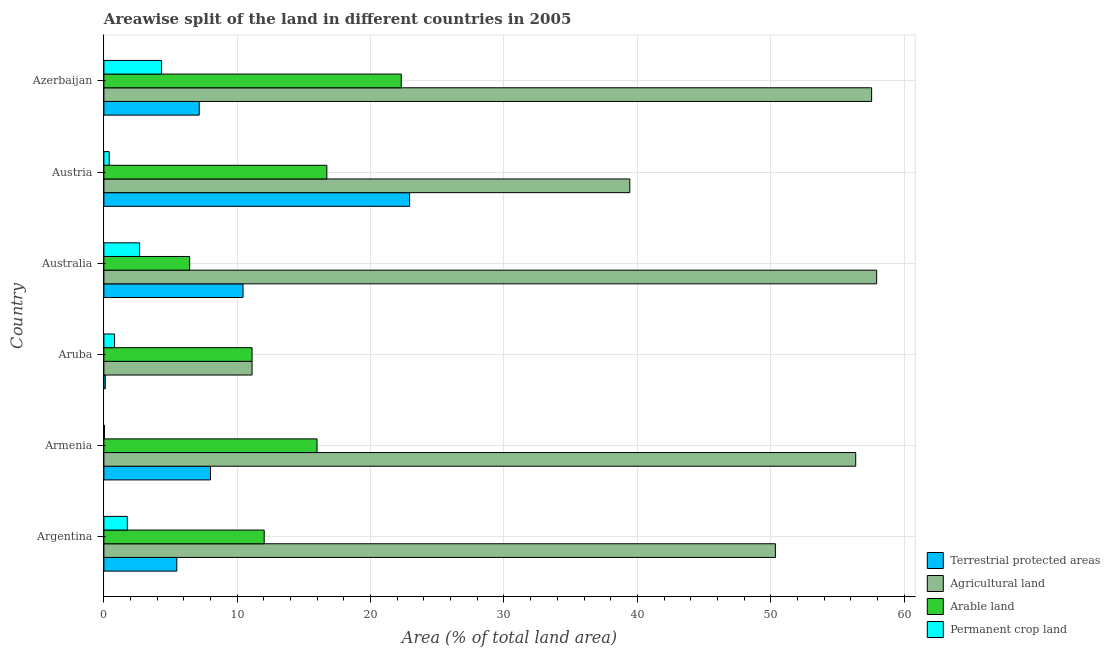How many different coloured bars are there?
Your answer should be compact. 4. Are the number of bars on each tick of the Y-axis equal?
Provide a succinct answer. Yes. How many bars are there on the 6th tick from the top?
Offer a terse response. 4. What is the label of the 1st group of bars from the top?
Your answer should be compact. Azerbaijan. What is the percentage of area under permanent crop land in Australia?
Keep it short and to the point. 2.68. Across all countries, what is the maximum percentage of area under permanent crop land?
Provide a short and direct response. 4.32. Across all countries, what is the minimum percentage of area under agricultural land?
Your answer should be very brief. 11.11. In which country was the percentage of area under agricultural land maximum?
Make the answer very short. Australia. In which country was the percentage of area under agricultural land minimum?
Give a very brief answer. Aruba. What is the total percentage of land under terrestrial protection in the graph?
Keep it short and to the point. 54.07. What is the difference between the percentage of area under agricultural land in Australia and that in Azerbaijan?
Provide a short and direct response. 0.38. What is the difference between the percentage of area under permanent crop land in Argentina and the percentage of land under terrestrial protection in Aruba?
Keep it short and to the point. 1.65. What is the average percentage of area under arable land per country?
Offer a terse response. 14.09. What is the difference between the percentage of area under agricultural land and percentage of area under arable land in Azerbaijan?
Your answer should be compact. 35.27. In how many countries, is the percentage of area under arable land greater than 36 %?
Provide a succinct answer. 0. What is the ratio of the percentage of area under agricultural land in Argentina to that in Australia?
Ensure brevity in your answer.  0.87. Is the difference between the percentage of area under agricultural land in Austria and Azerbaijan greater than the difference between the percentage of area under arable land in Austria and Azerbaijan?
Your answer should be very brief. No. What is the difference between the highest and the second highest percentage of area under agricultural land?
Your answer should be very brief. 0.38. What is the difference between the highest and the lowest percentage of area under agricultural land?
Your answer should be very brief. 46.83. In how many countries, is the percentage of area under agricultural land greater than the average percentage of area under agricultural land taken over all countries?
Your answer should be very brief. 4. Is the sum of the percentage of land under terrestrial protection in Armenia and Austria greater than the maximum percentage of area under arable land across all countries?
Provide a short and direct response. Yes. Is it the case that in every country, the sum of the percentage of area under agricultural land and percentage of area under arable land is greater than the sum of percentage of area under permanent crop land and percentage of land under terrestrial protection?
Offer a very short reply. No. What does the 4th bar from the top in Argentina represents?
Your answer should be very brief. Terrestrial protected areas. What does the 2nd bar from the bottom in Austria represents?
Provide a short and direct response. Agricultural land. What is the difference between two consecutive major ticks on the X-axis?
Offer a terse response. 10. Where does the legend appear in the graph?
Your answer should be compact. Bottom right. How are the legend labels stacked?
Make the answer very short. Vertical. What is the title of the graph?
Your response must be concise. Areawise split of the land in different countries in 2005. What is the label or title of the X-axis?
Make the answer very short. Area (% of total land area). What is the Area (% of total land area) of Terrestrial protected areas in Argentina?
Provide a succinct answer. 5.47. What is the Area (% of total land area) in Agricultural land in Argentina?
Provide a succinct answer. 50.35. What is the Area (% of total land area) of Arable land in Argentina?
Give a very brief answer. 12.02. What is the Area (% of total land area) in Permanent crop land in Argentina?
Provide a short and direct response. 1.76. What is the Area (% of total land area) of Terrestrial protected areas in Armenia?
Provide a short and direct response. 7.99. What is the Area (% of total land area) in Agricultural land in Armenia?
Make the answer very short. 56.38. What is the Area (% of total land area) in Arable land in Armenia?
Make the answer very short. 15.98. What is the Area (% of total land area) in Permanent crop land in Armenia?
Provide a short and direct response. 0.04. What is the Area (% of total land area) of Terrestrial protected areas in Aruba?
Provide a succinct answer. 0.11. What is the Area (% of total land area) in Agricultural land in Aruba?
Provide a succinct answer. 11.11. What is the Area (% of total land area) in Arable land in Aruba?
Ensure brevity in your answer.  11.11. What is the Area (% of total land area) in Permanent crop land in Aruba?
Provide a succinct answer. 0.8. What is the Area (% of total land area) of Terrestrial protected areas in Australia?
Your answer should be compact. 10.43. What is the Area (% of total land area) in Agricultural land in Australia?
Your answer should be compact. 57.94. What is the Area (% of total land area) of Arable land in Australia?
Your answer should be very brief. 6.43. What is the Area (% of total land area) of Permanent crop land in Australia?
Give a very brief answer. 2.68. What is the Area (% of total land area) in Terrestrial protected areas in Austria?
Your response must be concise. 22.92. What is the Area (% of total land area) in Agricultural land in Austria?
Offer a terse response. 39.44. What is the Area (% of total land area) in Arable land in Austria?
Provide a succinct answer. 16.72. What is the Area (% of total land area) in Permanent crop land in Austria?
Provide a succinct answer. 0.4. What is the Area (% of total land area) of Terrestrial protected areas in Azerbaijan?
Offer a terse response. 7.15. What is the Area (% of total land area) in Agricultural land in Azerbaijan?
Offer a terse response. 57.57. What is the Area (% of total land area) of Arable land in Azerbaijan?
Provide a short and direct response. 22.3. What is the Area (% of total land area) of Permanent crop land in Azerbaijan?
Offer a terse response. 4.32. Across all countries, what is the maximum Area (% of total land area) in Terrestrial protected areas?
Your answer should be compact. 22.92. Across all countries, what is the maximum Area (% of total land area) of Agricultural land?
Keep it short and to the point. 57.94. Across all countries, what is the maximum Area (% of total land area) in Arable land?
Your response must be concise. 22.3. Across all countries, what is the maximum Area (% of total land area) of Permanent crop land?
Offer a very short reply. 4.32. Across all countries, what is the minimum Area (% of total land area) of Terrestrial protected areas?
Make the answer very short. 0.11. Across all countries, what is the minimum Area (% of total land area) of Agricultural land?
Ensure brevity in your answer.  11.11. Across all countries, what is the minimum Area (% of total land area) of Arable land?
Your answer should be compact. 6.43. Across all countries, what is the minimum Area (% of total land area) in Permanent crop land?
Provide a short and direct response. 0.04. What is the total Area (% of total land area) in Terrestrial protected areas in the graph?
Provide a succinct answer. 54.07. What is the total Area (% of total land area) of Agricultural land in the graph?
Your answer should be compact. 272.79. What is the total Area (% of total land area) in Arable land in the graph?
Provide a short and direct response. 84.56. What is the total Area (% of total land area) in Permanent crop land in the graph?
Your answer should be very brief. 10. What is the difference between the Area (% of total land area) of Terrestrial protected areas in Argentina and that in Armenia?
Give a very brief answer. -2.53. What is the difference between the Area (% of total land area) of Agricultural land in Argentina and that in Armenia?
Offer a very short reply. -6.02. What is the difference between the Area (% of total land area) of Arable land in Argentina and that in Armenia?
Offer a terse response. -3.96. What is the difference between the Area (% of total land area) in Permanent crop land in Argentina and that in Armenia?
Give a very brief answer. 1.71. What is the difference between the Area (% of total land area) in Terrestrial protected areas in Argentina and that in Aruba?
Make the answer very short. 5.36. What is the difference between the Area (% of total land area) in Agricultural land in Argentina and that in Aruba?
Provide a short and direct response. 39.24. What is the difference between the Area (% of total land area) of Arable land in Argentina and that in Aruba?
Offer a very short reply. 0.91. What is the difference between the Area (% of total land area) of Terrestrial protected areas in Argentina and that in Australia?
Offer a terse response. -4.97. What is the difference between the Area (% of total land area) of Agricultural land in Argentina and that in Australia?
Your response must be concise. -7.59. What is the difference between the Area (% of total land area) of Arable land in Argentina and that in Australia?
Offer a very short reply. 5.59. What is the difference between the Area (% of total land area) in Permanent crop land in Argentina and that in Australia?
Ensure brevity in your answer.  -0.92. What is the difference between the Area (% of total land area) of Terrestrial protected areas in Argentina and that in Austria?
Your answer should be compact. -17.46. What is the difference between the Area (% of total land area) in Agricultural land in Argentina and that in Austria?
Offer a very short reply. 10.92. What is the difference between the Area (% of total land area) of Arable land in Argentina and that in Austria?
Offer a terse response. -4.7. What is the difference between the Area (% of total land area) in Permanent crop land in Argentina and that in Austria?
Ensure brevity in your answer.  1.36. What is the difference between the Area (% of total land area) of Terrestrial protected areas in Argentina and that in Azerbaijan?
Ensure brevity in your answer.  -1.68. What is the difference between the Area (% of total land area) in Agricultural land in Argentina and that in Azerbaijan?
Your response must be concise. -7.22. What is the difference between the Area (% of total land area) in Arable land in Argentina and that in Azerbaijan?
Keep it short and to the point. -10.28. What is the difference between the Area (% of total land area) of Permanent crop land in Argentina and that in Azerbaijan?
Your answer should be very brief. -2.57. What is the difference between the Area (% of total land area) of Terrestrial protected areas in Armenia and that in Aruba?
Provide a short and direct response. 7.89. What is the difference between the Area (% of total land area) of Agricultural land in Armenia and that in Aruba?
Offer a terse response. 45.26. What is the difference between the Area (% of total land area) of Arable land in Armenia and that in Aruba?
Ensure brevity in your answer.  4.87. What is the difference between the Area (% of total land area) in Permanent crop land in Armenia and that in Aruba?
Keep it short and to the point. -0.76. What is the difference between the Area (% of total land area) in Terrestrial protected areas in Armenia and that in Australia?
Give a very brief answer. -2.44. What is the difference between the Area (% of total land area) of Agricultural land in Armenia and that in Australia?
Your answer should be very brief. -1.57. What is the difference between the Area (% of total land area) of Arable land in Armenia and that in Australia?
Provide a succinct answer. 9.55. What is the difference between the Area (% of total land area) in Permanent crop land in Armenia and that in Australia?
Ensure brevity in your answer.  -2.64. What is the difference between the Area (% of total land area) of Terrestrial protected areas in Armenia and that in Austria?
Your response must be concise. -14.93. What is the difference between the Area (% of total land area) of Agricultural land in Armenia and that in Austria?
Your response must be concise. 16.94. What is the difference between the Area (% of total land area) in Arable land in Armenia and that in Austria?
Your response must be concise. -0.74. What is the difference between the Area (% of total land area) of Permanent crop land in Armenia and that in Austria?
Your answer should be compact. -0.36. What is the difference between the Area (% of total land area) in Terrestrial protected areas in Armenia and that in Azerbaijan?
Keep it short and to the point. 0.84. What is the difference between the Area (% of total land area) in Agricultural land in Armenia and that in Azerbaijan?
Your answer should be very brief. -1.19. What is the difference between the Area (% of total land area) in Arable land in Armenia and that in Azerbaijan?
Provide a succinct answer. -6.32. What is the difference between the Area (% of total land area) of Permanent crop land in Armenia and that in Azerbaijan?
Give a very brief answer. -4.28. What is the difference between the Area (% of total land area) of Terrestrial protected areas in Aruba and that in Australia?
Your response must be concise. -10.33. What is the difference between the Area (% of total land area) of Agricultural land in Aruba and that in Australia?
Give a very brief answer. -46.83. What is the difference between the Area (% of total land area) in Arable land in Aruba and that in Australia?
Your answer should be compact. 4.68. What is the difference between the Area (% of total land area) of Permanent crop land in Aruba and that in Australia?
Your answer should be compact. -1.88. What is the difference between the Area (% of total land area) of Terrestrial protected areas in Aruba and that in Austria?
Ensure brevity in your answer.  -22.82. What is the difference between the Area (% of total land area) in Agricultural land in Aruba and that in Austria?
Offer a terse response. -28.33. What is the difference between the Area (% of total land area) in Arable land in Aruba and that in Austria?
Make the answer very short. -5.61. What is the difference between the Area (% of total land area) of Permanent crop land in Aruba and that in Austria?
Provide a succinct answer. 0.4. What is the difference between the Area (% of total land area) in Terrestrial protected areas in Aruba and that in Azerbaijan?
Your response must be concise. -7.04. What is the difference between the Area (% of total land area) of Agricultural land in Aruba and that in Azerbaijan?
Your response must be concise. -46.46. What is the difference between the Area (% of total land area) of Arable land in Aruba and that in Azerbaijan?
Keep it short and to the point. -11.19. What is the difference between the Area (% of total land area) of Permanent crop land in Aruba and that in Azerbaijan?
Your response must be concise. -3.53. What is the difference between the Area (% of total land area) of Terrestrial protected areas in Australia and that in Austria?
Your response must be concise. -12.49. What is the difference between the Area (% of total land area) of Agricultural land in Australia and that in Austria?
Give a very brief answer. 18.51. What is the difference between the Area (% of total land area) of Arable land in Australia and that in Austria?
Your answer should be compact. -10.29. What is the difference between the Area (% of total land area) of Permanent crop land in Australia and that in Austria?
Provide a short and direct response. 2.28. What is the difference between the Area (% of total land area) in Terrestrial protected areas in Australia and that in Azerbaijan?
Provide a succinct answer. 3.28. What is the difference between the Area (% of total land area) in Agricultural land in Australia and that in Azerbaijan?
Give a very brief answer. 0.38. What is the difference between the Area (% of total land area) of Arable land in Australia and that in Azerbaijan?
Provide a short and direct response. -15.87. What is the difference between the Area (% of total land area) in Permanent crop land in Australia and that in Azerbaijan?
Your response must be concise. -1.64. What is the difference between the Area (% of total land area) of Terrestrial protected areas in Austria and that in Azerbaijan?
Offer a terse response. 15.78. What is the difference between the Area (% of total land area) of Agricultural land in Austria and that in Azerbaijan?
Offer a terse response. -18.13. What is the difference between the Area (% of total land area) in Arable land in Austria and that in Azerbaijan?
Offer a terse response. -5.58. What is the difference between the Area (% of total land area) of Permanent crop land in Austria and that in Azerbaijan?
Keep it short and to the point. -3.92. What is the difference between the Area (% of total land area) of Terrestrial protected areas in Argentina and the Area (% of total land area) of Agricultural land in Armenia?
Provide a short and direct response. -50.91. What is the difference between the Area (% of total land area) of Terrestrial protected areas in Argentina and the Area (% of total land area) of Arable land in Armenia?
Ensure brevity in your answer.  -10.52. What is the difference between the Area (% of total land area) of Terrestrial protected areas in Argentina and the Area (% of total land area) of Permanent crop land in Armenia?
Make the answer very short. 5.42. What is the difference between the Area (% of total land area) in Agricultural land in Argentina and the Area (% of total land area) in Arable land in Armenia?
Provide a short and direct response. 34.37. What is the difference between the Area (% of total land area) in Agricultural land in Argentina and the Area (% of total land area) in Permanent crop land in Armenia?
Give a very brief answer. 50.31. What is the difference between the Area (% of total land area) of Arable land in Argentina and the Area (% of total land area) of Permanent crop land in Armenia?
Ensure brevity in your answer.  11.98. What is the difference between the Area (% of total land area) of Terrestrial protected areas in Argentina and the Area (% of total land area) of Agricultural land in Aruba?
Make the answer very short. -5.64. What is the difference between the Area (% of total land area) of Terrestrial protected areas in Argentina and the Area (% of total land area) of Arable land in Aruba?
Make the answer very short. -5.64. What is the difference between the Area (% of total land area) in Terrestrial protected areas in Argentina and the Area (% of total land area) in Permanent crop land in Aruba?
Offer a terse response. 4.67. What is the difference between the Area (% of total land area) in Agricultural land in Argentina and the Area (% of total land area) in Arable land in Aruba?
Provide a short and direct response. 39.24. What is the difference between the Area (% of total land area) in Agricultural land in Argentina and the Area (% of total land area) in Permanent crop land in Aruba?
Offer a very short reply. 49.55. What is the difference between the Area (% of total land area) of Arable land in Argentina and the Area (% of total land area) of Permanent crop land in Aruba?
Give a very brief answer. 11.22. What is the difference between the Area (% of total land area) in Terrestrial protected areas in Argentina and the Area (% of total land area) in Agricultural land in Australia?
Provide a succinct answer. -52.48. What is the difference between the Area (% of total land area) of Terrestrial protected areas in Argentina and the Area (% of total land area) of Arable land in Australia?
Your response must be concise. -0.96. What is the difference between the Area (% of total land area) of Terrestrial protected areas in Argentina and the Area (% of total land area) of Permanent crop land in Australia?
Make the answer very short. 2.79. What is the difference between the Area (% of total land area) in Agricultural land in Argentina and the Area (% of total land area) in Arable land in Australia?
Provide a succinct answer. 43.92. What is the difference between the Area (% of total land area) in Agricultural land in Argentina and the Area (% of total land area) in Permanent crop land in Australia?
Keep it short and to the point. 47.67. What is the difference between the Area (% of total land area) of Arable land in Argentina and the Area (% of total land area) of Permanent crop land in Australia?
Keep it short and to the point. 9.34. What is the difference between the Area (% of total land area) of Terrestrial protected areas in Argentina and the Area (% of total land area) of Agricultural land in Austria?
Offer a very short reply. -33.97. What is the difference between the Area (% of total land area) in Terrestrial protected areas in Argentina and the Area (% of total land area) in Arable land in Austria?
Keep it short and to the point. -11.25. What is the difference between the Area (% of total land area) of Terrestrial protected areas in Argentina and the Area (% of total land area) of Permanent crop land in Austria?
Keep it short and to the point. 5.07. What is the difference between the Area (% of total land area) of Agricultural land in Argentina and the Area (% of total land area) of Arable land in Austria?
Your answer should be compact. 33.63. What is the difference between the Area (% of total land area) in Agricultural land in Argentina and the Area (% of total land area) in Permanent crop land in Austria?
Make the answer very short. 49.95. What is the difference between the Area (% of total land area) in Arable land in Argentina and the Area (% of total land area) in Permanent crop land in Austria?
Keep it short and to the point. 11.62. What is the difference between the Area (% of total land area) in Terrestrial protected areas in Argentina and the Area (% of total land area) in Agricultural land in Azerbaijan?
Your response must be concise. -52.1. What is the difference between the Area (% of total land area) in Terrestrial protected areas in Argentina and the Area (% of total land area) in Arable land in Azerbaijan?
Offer a very short reply. -16.83. What is the difference between the Area (% of total land area) in Terrestrial protected areas in Argentina and the Area (% of total land area) in Permanent crop land in Azerbaijan?
Your answer should be very brief. 1.14. What is the difference between the Area (% of total land area) of Agricultural land in Argentina and the Area (% of total land area) of Arable land in Azerbaijan?
Make the answer very short. 28.05. What is the difference between the Area (% of total land area) in Agricultural land in Argentina and the Area (% of total land area) in Permanent crop land in Azerbaijan?
Offer a very short reply. 46.03. What is the difference between the Area (% of total land area) of Arable land in Argentina and the Area (% of total land area) of Permanent crop land in Azerbaijan?
Provide a succinct answer. 7.7. What is the difference between the Area (% of total land area) in Terrestrial protected areas in Armenia and the Area (% of total land area) in Agricultural land in Aruba?
Keep it short and to the point. -3.12. What is the difference between the Area (% of total land area) in Terrestrial protected areas in Armenia and the Area (% of total land area) in Arable land in Aruba?
Ensure brevity in your answer.  -3.12. What is the difference between the Area (% of total land area) in Terrestrial protected areas in Armenia and the Area (% of total land area) in Permanent crop land in Aruba?
Give a very brief answer. 7.19. What is the difference between the Area (% of total land area) in Agricultural land in Armenia and the Area (% of total land area) in Arable land in Aruba?
Your response must be concise. 45.26. What is the difference between the Area (% of total land area) in Agricultural land in Armenia and the Area (% of total land area) in Permanent crop land in Aruba?
Your response must be concise. 55.58. What is the difference between the Area (% of total land area) of Arable land in Armenia and the Area (% of total land area) of Permanent crop land in Aruba?
Your answer should be compact. 15.18. What is the difference between the Area (% of total land area) of Terrestrial protected areas in Armenia and the Area (% of total land area) of Agricultural land in Australia?
Your answer should be compact. -49.95. What is the difference between the Area (% of total land area) in Terrestrial protected areas in Armenia and the Area (% of total land area) in Arable land in Australia?
Your answer should be very brief. 1.56. What is the difference between the Area (% of total land area) of Terrestrial protected areas in Armenia and the Area (% of total land area) of Permanent crop land in Australia?
Offer a very short reply. 5.31. What is the difference between the Area (% of total land area) in Agricultural land in Armenia and the Area (% of total land area) in Arable land in Australia?
Keep it short and to the point. 49.94. What is the difference between the Area (% of total land area) of Agricultural land in Armenia and the Area (% of total land area) of Permanent crop land in Australia?
Your answer should be compact. 53.7. What is the difference between the Area (% of total land area) of Arable land in Armenia and the Area (% of total land area) of Permanent crop land in Australia?
Offer a terse response. 13.3. What is the difference between the Area (% of total land area) of Terrestrial protected areas in Armenia and the Area (% of total land area) of Agricultural land in Austria?
Make the answer very short. -31.44. What is the difference between the Area (% of total land area) in Terrestrial protected areas in Armenia and the Area (% of total land area) in Arable land in Austria?
Ensure brevity in your answer.  -8.73. What is the difference between the Area (% of total land area) of Terrestrial protected areas in Armenia and the Area (% of total land area) of Permanent crop land in Austria?
Your answer should be compact. 7.59. What is the difference between the Area (% of total land area) of Agricultural land in Armenia and the Area (% of total land area) of Arable land in Austria?
Keep it short and to the point. 39.66. What is the difference between the Area (% of total land area) of Agricultural land in Armenia and the Area (% of total land area) of Permanent crop land in Austria?
Offer a terse response. 55.98. What is the difference between the Area (% of total land area) in Arable land in Armenia and the Area (% of total land area) in Permanent crop land in Austria?
Give a very brief answer. 15.58. What is the difference between the Area (% of total land area) of Terrestrial protected areas in Armenia and the Area (% of total land area) of Agricultural land in Azerbaijan?
Your response must be concise. -49.58. What is the difference between the Area (% of total land area) of Terrestrial protected areas in Armenia and the Area (% of total land area) of Arable land in Azerbaijan?
Give a very brief answer. -14.31. What is the difference between the Area (% of total land area) of Terrestrial protected areas in Armenia and the Area (% of total land area) of Permanent crop land in Azerbaijan?
Keep it short and to the point. 3.67. What is the difference between the Area (% of total land area) in Agricultural land in Armenia and the Area (% of total land area) in Arable land in Azerbaijan?
Provide a succinct answer. 34.08. What is the difference between the Area (% of total land area) of Agricultural land in Armenia and the Area (% of total land area) of Permanent crop land in Azerbaijan?
Offer a terse response. 52.05. What is the difference between the Area (% of total land area) of Arable land in Armenia and the Area (% of total land area) of Permanent crop land in Azerbaijan?
Offer a terse response. 11.66. What is the difference between the Area (% of total land area) in Terrestrial protected areas in Aruba and the Area (% of total land area) in Agricultural land in Australia?
Your response must be concise. -57.84. What is the difference between the Area (% of total land area) of Terrestrial protected areas in Aruba and the Area (% of total land area) of Arable land in Australia?
Offer a terse response. -6.33. What is the difference between the Area (% of total land area) in Terrestrial protected areas in Aruba and the Area (% of total land area) in Permanent crop land in Australia?
Provide a short and direct response. -2.57. What is the difference between the Area (% of total land area) in Agricultural land in Aruba and the Area (% of total land area) in Arable land in Australia?
Provide a short and direct response. 4.68. What is the difference between the Area (% of total land area) of Agricultural land in Aruba and the Area (% of total land area) of Permanent crop land in Australia?
Your answer should be very brief. 8.43. What is the difference between the Area (% of total land area) in Arable land in Aruba and the Area (% of total land area) in Permanent crop land in Australia?
Give a very brief answer. 8.43. What is the difference between the Area (% of total land area) of Terrestrial protected areas in Aruba and the Area (% of total land area) of Agricultural land in Austria?
Make the answer very short. -39.33. What is the difference between the Area (% of total land area) in Terrestrial protected areas in Aruba and the Area (% of total land area) in Arable land in Austria?
Provide a succinct answer. -16.61. What is the difference between the Area (% of total land area) in Terrestrial protected areas in Aruba and the Area (% of total land area) in Permanent crop land in Austria?
Your response must be concise. -0.29. What is the difference between the Area (% of total land area) in Agricultural land in Aruba and the Area (% of total land area) in Arable land in Austria?
Your answer should be compact. -5.61. What is the difference between the Area (% of total land area) of Agricultural land in Aruba and the Area (% of total land area) of Permanent crop land in Austria?
Your response must be concise. 10.71. What is the difference between the Area (% of total land area) of Arable land in Aruba and the Area (% of total land area) of Permanent crop land in Austria?
Provide a short and direct response. 10.71. What is the difference between the Area (% of total land area) in Terrestrial protected areas in Aruba and the Area (% of total land area) in Agricultural land in Azerbaijan?
Give a very brief answer. -57.46. What is the difference between the Area (% of total land area) of Terrestrial protected areas in Aruba and the Area (% of total land area) of Arable land in Azerbaijan?
Offer a very short reply. -22.19. What is the difference between the Area (% of total land area) of Terrestrial protected areas in Aruba and the Area (% of total land area) of Permanent crop land in Azerbaijan?
Your answer should be very brief. -4.22. What is the difference between the Area (% of total land area) of Agricultural land in Aruba and the Area (% of total land area) of Arable land in Azerbaijan?
Ensure brevity in your answer.  -11.19. What is the difference between the Area (% of total land area) of Agricultural land in Aruba and the Area (% of total land area) of Permanent crop land in Azerbaijan?
Make the answer very short. 6.79. What is the difference between the Area (% of total land area) of Arable land in Aruba and the Area (% of total land area) of Permanent crop land in Azerbaijan?
Your answer should be very brief. 6.79. What is the difference between the Area (% of total land area) in Terrestrial protected areas in Australia and the Area (% of total land area) in Agricultural land in Austria?
Your response must be concise. -29. What is the difference between the Area (% of total land area) of Terrestrial protected areas in Australia and the Area (% of total land area) of Arable land in Austria?
Offer a terse response. -6.29. What is the difference between the Area (% of total land area) of Terrestrial protected areas in Australia and the Area (% of total land area) of Permanent crop land in Austria?
Offer a terse response. 10.03. What is the difference between the Area (% of total land area) of Agricultural land in Australia and the Area (% of total land area) of Arable land in Austria?
Your response must be concise. 41.23. What is the difference between the Area (% of total land area) of Agricultural land in Australia and the Area (% of total land area) of Permanent crop land in Austria?
Keep it short and to the point. 57.55. What is the difference between the Area (% of total land area) of Arable land in Australia and the Area (% of total land area) of Permanent crop land in Austria?
Provide a short and direct response. 6.03. What is the difference between the Area (% of total land area) of Terrestrial protected areas in Australia and the Area (% of total land area) of Agricultural land in Azerbaijan?
Offer a very short reply. -47.14. What is the difference between the Area (% of total land area) of Terrestrial protected areas in Australia and the Area (% of total land area) of Arable land in Azerbaijan?
Make the answer very short. -11.87. What is the difference between the Area (% of total land area) of Terrestrial protected areas in Australia and the Area (% of total land area) of Permanent crop land in Azerbaijan?
Give a very brief answer. 6.11. What is the difference between the Area (% of total land area) in Agricultural land in Australia and the Area (% of total land area) in Arable land in Azerbaijan?
Offer a terse response. 35.65. What is the difference between the Area (% of total land area) in Agricultural land in Australia and the Area (% of total land area) in Permanent crop land in Azerbaijan?
Your answer should be very brief. 53.62. What is the difference between the Area (% of total land area) in Arable land in Australia and the Area (% of total land area) in Permanent crop land in Azerbaijan?
Offer a very short reply. 2.11. What is the difference between the Area (% of total land area) in Terrestrial protected areas in Austria and the Area (% of total land area) in Agricultural land in Azerbaijan?
Make the answer very short. -34.64. What is the difference between the Area (% of total land area) in Terrestrial protected areas in Austria and the Area (% of total land area) in Arable land in Azerbaijan?
Make the answer very short. 0.63. What is the difference between the Area (% of total land area) in Terrestrial protected areas in Austria and the Area (% of total land area) in Permanent crop land in Azerbaijan?
Your response must be concise. 18.6. What is the difference between the Area (% of total land area) of Agricultural land in Austria and the Area (% of total land area) of Arable land in Azerbaijan?
Offer a very short reply. 17.14. What is the difference between the Area (% of total land area) in Agricultural land in Austria and the Area (% of total land area) in Permanent crop land in Azerbaijan?
Provide a succinct answer. 35.11. What is the difference between the Area (% of total land area) in Arable land in Austria and the Area (% of total land area) in Permanent crop land in Azerbaijan?
Your answer should be compact. 12.39. What is the average Area (% of total land area) of Terrestrial protected areas per country?
Offer a very short reply. 9.01. What is the average Area (% of total land area) of Agricultural land per country?
Offer a terse response. 45.46. What is the average Area (% of total land area) of Arable land per country?
Give a very brief answer. 14.09. What is the average Area (% of total land area) of Permanent crop land per country?
Provide a succinct answer. 1.67. What is the difference between the Area (% of total land area) of Terrestrial protected areas and Area (% of total land area) of Agricultural land in Argentina?
Your response must be concise. -44.89. What is the difference between the Area (% of total land area) of Terrestrial protected areas and Area (% of total land area) of Arable land in Argentina?
Keep it short and to the point. -6.55. What is the difference between the Area (% of total land area) in Terrestrial protected areas and Area (% of total land area) in Permanent crop land in Argentina?
Your response must be concise. 3.71. What is the difference between the Area (% of total land area) in Agricultural land and Area (% of total land area) in Arable land in Argentina?
Keep it short and to the point. 38.33. What is the difference between the Area (% of total land area) of Agricultural land and Area (% of total land area) of Permanent crop land in Argentina?
Offer a very short reply. 48.6. What is the difference between the Area (% of total land area) in Arable land and Area (% of total land area) in Permanent crop land in Argentina?
Offer a terse response. 10.26. What is the difference between the Area (% of total land area) in Terrestrial protected areas and Area (% of total land area) in Agricultural land in Armenia?
Keep it short and to the point. -48.38. What is the difference between the Area (% of total land area) of Terrestrial protected areas and Area (% of total land area) of Arable land in Armenia?
Your answer should be very brief. -7.99. What is the difference between the Area (% of total land area) in Terrestrial protected areas and Area (% of total land area) in Permanent crop land in Armenia?
Keep it short and to the point. 7.95. What is the difference between the Area (% of total land area) of Agricultural land and Area (% of total land area) of Arable land in Armenia?
Provide a succinct answer. 40.39. What is the difference between the Area (% of total land area) in Agricultural land and Area (% of total land area) in Permanent crop land in Armenia?
Provide a short and direct response. 56.33. What is the difference between the Area (% of total land area) of Arable land and Area (% of total land area) of Permanent crop land in Armenia?
Give a very brief answer. 15.94. What is the difference between the Area (% of total land area) of Terrestrial protected areas and Area (% of total land area) of Agricultural land in Aruba?
Offer a very short reply. -11.01. What is the difference between the Area (% of total land area) of Terrestrial protected areas and Area (% of total land area) of Arable land in Aruba?
Keep it short and to the point. -11.01. What is the difference between the Area (% of total land area) in Terrestrial protected areas and Area (% of total land area) in Permanent crop land in Aruba?
Provide a short and direct response. -0.69. What is the difference between the Area (% of total land area) in Agricultural land and Area (% of total land area) in Permanent crop land in Aruba?
Your response must be concise. 10.31. What is the difference between the Area (% of total land area) in Arable land and Area (% of total land area) in Permanent crop land in Aruba?
Ensure brevity in your answer.  10.31. What is the difference between the Area (% of total land area) of Terrestrial protected areas and Area (% of total land area) of Agricultural land in Australia?
Your response must be concise. -47.51. What is the difference between the Area (% of total land area) in Terrestrial protected areas and Area (% of total land area) in Arable land in Australia?
Make the answer very short. 4. What is the difference between the Area (% of total land area) in Terrestrial protected areas and Area (% of total land area) in Permanent crop land in Australia?
Keep it short and to the point. 7.75. What is the difference between the Area (% of total land area) of Agricultural land and Area (% of total land area) of Arable land in Australia?
Offer a terse response. 51.51. What is the difference between the Area (% of total land area) in Agricultural land and Area (% of total land area) in Permanent crop land in Australia?
Offer a terse response. 55.27. What is the difference between the Area (% of total land area) in Arable land and Area (% of total land area) in Permanent crop land in Australia?
Ensure brevity in your answer.  3.75. What is the difference between the Area (% of total land area) of Terrestrial protected areas and Area (% of total land area) of Agricultural land in Austria?
Give a very brief answer. -16.51. What is the difference between the Area (% of total land area) in Terrestrial protected areas and Area (% of total land area) in Arable land in Austria?
Make the answer very short. 6.21. What is the difference between the Area (% of total land area) in Terrestrial protected areas and Area (% of total land area) in Permanent crop land in Austria?
Provide a short and direct response. 22.53. What is the difference between the Area (% of total land area) in Agricultural land and Area (% of total land area) in Arable land in Austria?
Give a very brief answer. 22.72. What is the difference between the Area (% of total land area) in Agricultural land and Area (% of total land area) in Permanent crop land in Austria?
Make the answer very short. 39.04. What is the difference between the Area (% of total land area) in Arable land and Area (% of total land area) in Permanent crop land in Austria?
Your response must be concise. 16.32. What is the difference between the Area (% of total land area) in Terrestrial protected areas and Area (% of total land area) in Agricultural land in Azerbaijan?
Give a very brief answer. -50.42. What is the difference between the Area (% of total land area) in Terrestrial protected areas and Area (% of total land area) in Arable land in Azerbaijan?
Keep it short and to the point. -15.15. What is the difference between the Area (% of total land area) of Terrestrial protected areas and Area (% of total land area) of Permanent crop land in Azerbaijan?
Your answer should be very brief. 2.83. What is the difference between the Area (% of total land area) of Agricultural land and Area (% of total land area) of Arable land in Azerbaijan?
Your answer should be very brief. 35.27. What is the difference between the Area (% of total land area) of Agricultural land and Area (% of total land area) of Permanent crop land in Azerbaijan?
Ensure brevity in your answer.  53.24. What is the difference between the Area (% of total land area) of Arable land and Area (% of total land area) of Permanent crop land in Azerbaijan?
Offer a very short reply. 17.97. What is the ratio of the Area (% of total land area) of Terrestrial protected areas in Argentina to that in Armenia?
Make the answer very short. 0.68. What is the ratio of the Area (% of total land area) of Agricultural land in Argentina to that in Armenia?
Give a very brief answer. 0.89. What is the ratio of the Area (% of total land area) in Arable land in Argentina to that in Armenia?
Keep it short and to the point. 0.75. What is the ratio of the Area (% of total land area) in Permanent crop land in Argentina to that in Armenia?
Your response must be concise. 39.68. What is the ratio of the Area (% of total land area) of Terrestrial protected areas in Argentina to that in Aruba?
Your response must be concise. 51.79. What is the ratio of the Area (% of total land area) in Agricultural land in Argentina to that in Aruba?
Offer a terse response. 4.53. What is the ratio of the Area (% of total land area) in Arable land in Argentina to that in Aruba?
Ensure brevity in your answer.  1.08. What is the ratio of the Area (% of total land area) in Permanent crop land in Argentina to that in Aruba?
Your response must be concise. 2.2. What is the ratio of the Area (% of total land area) in Terrestrial protected areas in Argentina to that in Australia?
Keep it short and to the point. 0.52. What is the ratio of the Area (% of total land area) of Agricultural land in Argentina to that in Australia?
Make the answer very short. 0.87. What is the ratio of the Area (% of total land area) of Arable land in Argentina to that in Australia?
Keep it short and to the point. 1.87. What is the ratio of the Area (% of total land area) of Permanent crop land in Argentina to that in Australia?
Make the answer very short. 0.66. What is the ratio of the Area (% of total land area) of Terrestrial protected areas in Argentina to that in Austria?
Give a very brief answer. 0.24. What is the ratio of the Area (% of total land area) in Agricultural land in Argentina to that in Austria?
Keep it short and to the point. 1.28. What is the ratio of the Area (% of total land area) in Arable land in Argentina to that in Austria?
Your response must be concise. 0.72. What is the ratio of the Area (% of total land area) of Permanent crop land in Argentina to that in Austria?
Provide a succinct answer. 4.39. What is the ratio of the Area (% of total land area) in Terrestrial protected areas in Argentina to that in Azerbaijan?
Your answer should be very brief. 0.76. What is the ratio of the Area (% of total land area) in Agricultural land in Argentina to that in Azerbaijan?
Provide a succinct answer. 0.87. What is the ratio of the Area (% of total land area) in Arable land in Argentina to that in Azerbaijan?
Offer a terse response. 0.54. What is the ratio of the Area (% of total land area) in Permanent crop land in Argentina to that in Azerbaijan?
Provide a succinct answer. 0.41. What is the ratio of the Area (% of total land area) in Terrestrial protected areas in Armenia to that in Aruba?
Make the answer very short. 75.72. What is the ratio of the Area (% of total land area) of Agricultural land in Armenia to that in Aruba?
Offer a very short reply. 5.07. What is the ratio of the Area (% of total land area) in Arable land in Armenia to that in Aruba?
Your answer should be very brief. 1.44. What is the ratio of the Area (% of total land area) of Permanent crop land in Armenia to that in Aruba?
Your response must be concise. 0.06. What is the ratio of the Area (% of total land area) of Terrestrial protected areas in Armenia to that in Australia?
Keep it short and to the point. 0.77. What is the ratio of the Area (% of total land area) of Agricultural land in Armenia to that in Australia?
Ensure brevity in your answer.  0.97. What is the ratio of the Area (% of total land area) in Arable land in Armenia to that in Australia?
Your answer should be compact. 2.49. What is the ratio of the Area (% of total land area) in Permanent crop land in Armenia to that in Australia?
Your response must be concise. 0.02. What is the ratio of the Area (% of total land area) in Terrestrial protected areas in Armenia to that in Austria?
Provide a succinct answer. 0.35. What is the ratio of the Area (% of total land area) in Agricultural land in Armenia to that in Austria?
Offer a terse response. 1.43. What is the ratio of the Area (% of total land area) in Arable land in Armenia to that in Austria?
Give a very brief answer. 0.96. What is the ratio of the Area (% of total land area) in Permanent crop land in Armenia to that in Austria?
Your answer should be compact. 0.11. What is the ratio of the Area (% of total land area) in Terrestrial protected areas in Armenia to that in Azerbaijan?
Offer a terse response. 1.12. What is the ratio of the Area (% of total land area) in Agricultural land in Armenia to that in Azerbaijan?
Ensure brevity in your answer.  0.98. What is the ratio of the Area (% of total land area) in Arable land in Armenia to that in Azerbaijan?
Give a very brief answer. 0.72. What is the ratio of the Area (% of total land area) in Permanent crop land in Armenia to that in Azerbaijan?
Your answer should be very brief. 0.01. What is the ratio of the Area (% of total land area) of Terrestrial protected areas in Aruba to that in Australia?
Provide a short and direct response. 0.01. What is the ratio of the Area (% of total land area) in Agricultural land in Aruba to that in Australia?
Your answer should be very brief. 0.19. What is the ratio of the Area (% of total land area) of Arable land in Aruba to that in Australia?
Ensure brevity in your answer.  1.73. What is the ratio of the Area (% of total land area) of Permanent crop land in Aruba to that in Australia?
Offer a very short reply. 0.3. What is the ratio of the Area (% of total land area) in Terrestrial protected areas in Aruba to that in Austria?
Your answer should be very brief. 0. What is the ratio of the Area (% of total land area) in Agricultural land in Aruba to that in Austria?
Your answer should be compact. 0.28. What is the ratio of the Area (% of total land area) in Arable land in Aruba to that in Austria?
Provide a short and direct response. 0.66. What is the ratio of the Area (% of total land area) in Permanent crop land in Aruba to that in Austria?
Ensure brevity in your answer.  2. What is the ratio of the Area (% of total land area) in Terrestrial protected areas in Aruba to that in Azerbaijan?
Keep it short and to the point. 0.01. What is the ratio of the Area (% of total land area) in Agricultural land in Aruba to that in Azerbaijan?
Your answer should be compact. 0.19. What is the ratio of the Area (% of total land area) of Arable land in Aruba to that in Azerbaijan?
Your response must be concise. 0.5. What is the ratio of the Area (% of total land area) of Permanent crop land in Aruba to that in Azerbaijan?
Provide a short and direct response. 0.18. What is the ratio of the Area (% of total land area) in Terrestrial protected areas in Australia to that in Austria?
Provide a short and direct response. 0.46. What is the ratio of the Area (% of total land area) of Agricultural land in Australia to that in Austria?
Give a very brief answer. 1.47. What is the ratio of the Area (% of total land area) in Arable land in Australia to that in Austria?
Your response must be concise. 0.38. What is the ratio of the Area (% of total land area) of Permanent crop land in Australia to that in Austria?
Ensure brevity in your answer.  6.71. What is the ratio of the Area (% of total land area) in Terrestrial protected areas in Australia to that in Azerbaijan?
Ensure brevity in your answer.  1.46. What is the ratio of the Area (% of total land area) in Arable land in Australia to that in Azerbaijan?
Provide a short and direct response. 0.29. What is the ratio of the Area (% of total land area) of Permanent crop land in Australia to that in Azerbaijan?
Offer a very short reply. 0.62. What is the ratio of the Area (% of total land area) in Terrestrial protected areas in Austria to that in Azerbaijan?
Give a very brief answer. 3.21. What is the ratio of the Area (% of total land area) in Agricultural land in Austria to that in Azerbaijan?
Provide a short and direct response. 0.69. What is the ratio of the Area (% of total land area) in Arable land in Austria to that in Azerbaijan?
Provide a succinct answer. 0.75. What is the ratio of the Area (% of total land area) of Permanent crop land in Austria to that in Azerbaijan?
Keep it short and to the point. 0.09. What is the difference between the highest and the second highest Area (% of total land area) in Terrestrial protected areas?
Your answer should be compact. 12.49. What is the difference between the highest and the second highest Area (% of total land area) of Agricultural land?
Provide a short and direct response. 0.38. What is the difference between the highest and the second highest Area (% of total land area) in Arable land?
Your answer should be compact. 5.58. What is the difference between the highest and the second highest Area (% of total land area) of Permanent crop land?
Keep it short and to the point. 1.64. What is the difference between the highest and the lowest Area (% of total land area) of Terrestrial protected areas?
Provide a short and direct response. 22.82. What is the difference between the highest and the lowest Area (% of total land area) in Agricultural land?
Your answer should be very brief. 46.83. What is the difference between the highest and the lowest Area (% of total land area) of Arable land?
Ensure brevity in your answer.  15.87. What is the difference between the highest and the lowest Area (% of total land area) of Permanent crop land?
Offer a very short reply. 4.28. 